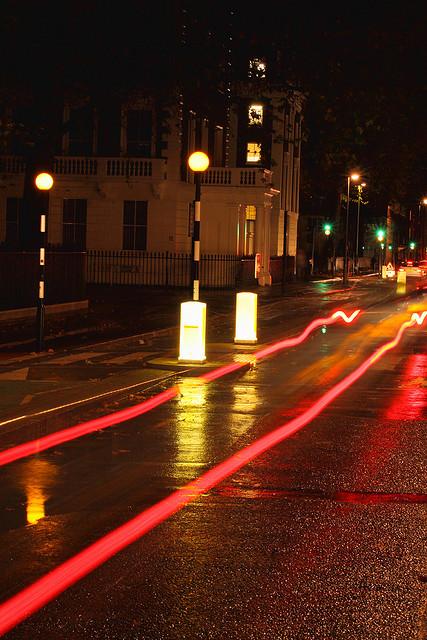What sort of photography was used to capture the blurred red line?
Answer briefly. Stop motion. Is it nighttime?
Answer briefly. Yes. What are the red lines on the road?
Concise answer only. Lights. 